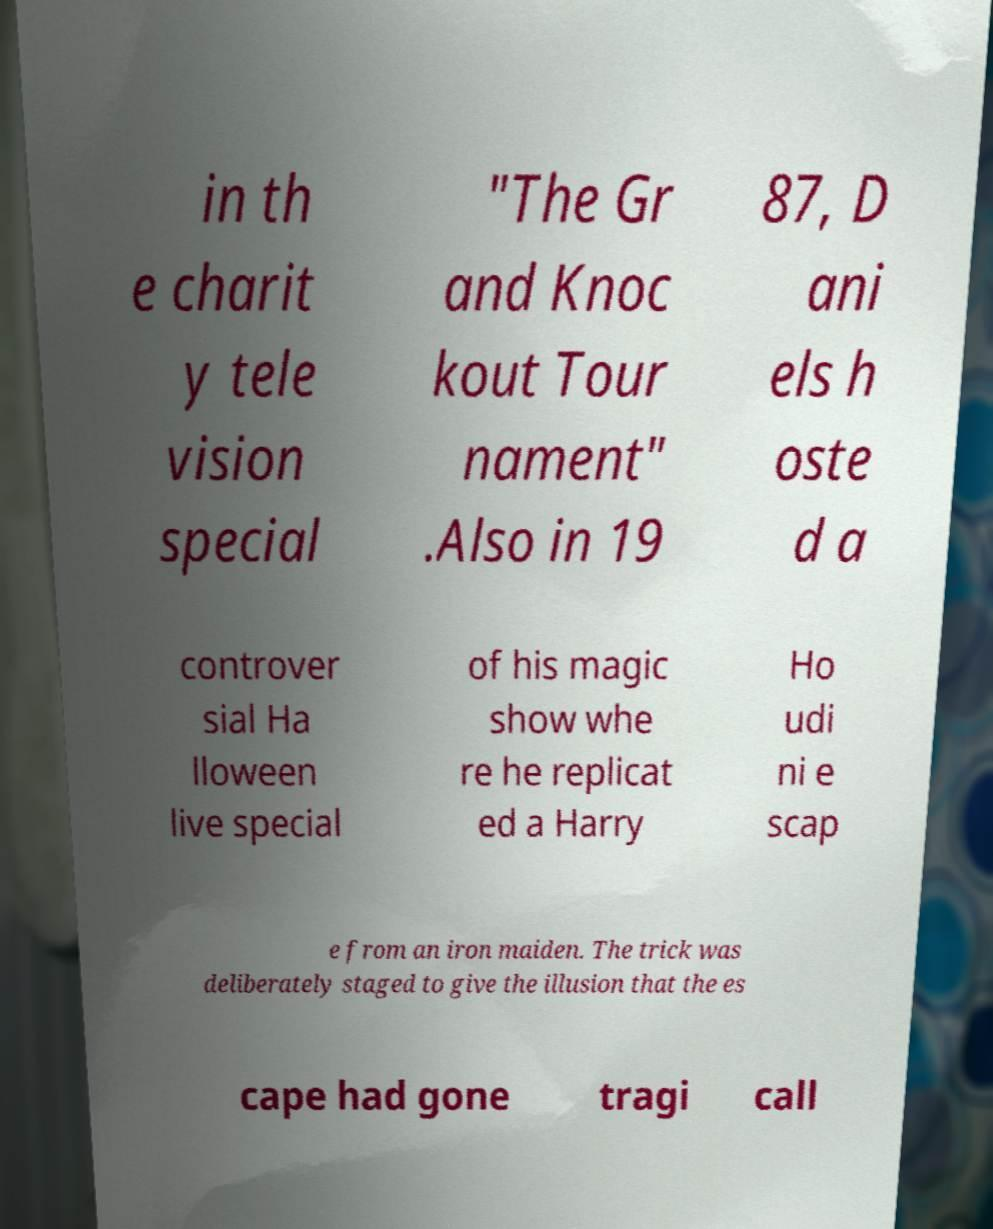There's text embedded in this image that I need extracted. Can you transcribe it verbatim? in th e charit y tele vision special "The Gr and Knoc kout Tour nament" .Also in 19 87, D ani els h oste d a controver sial Ha lloween live special of his magic show whe re he replicat ed a Harry Ho udi ni e scap e from an iron maiden. The trick was deliberately staged to give the illusion that the es cape had gone tragi call 